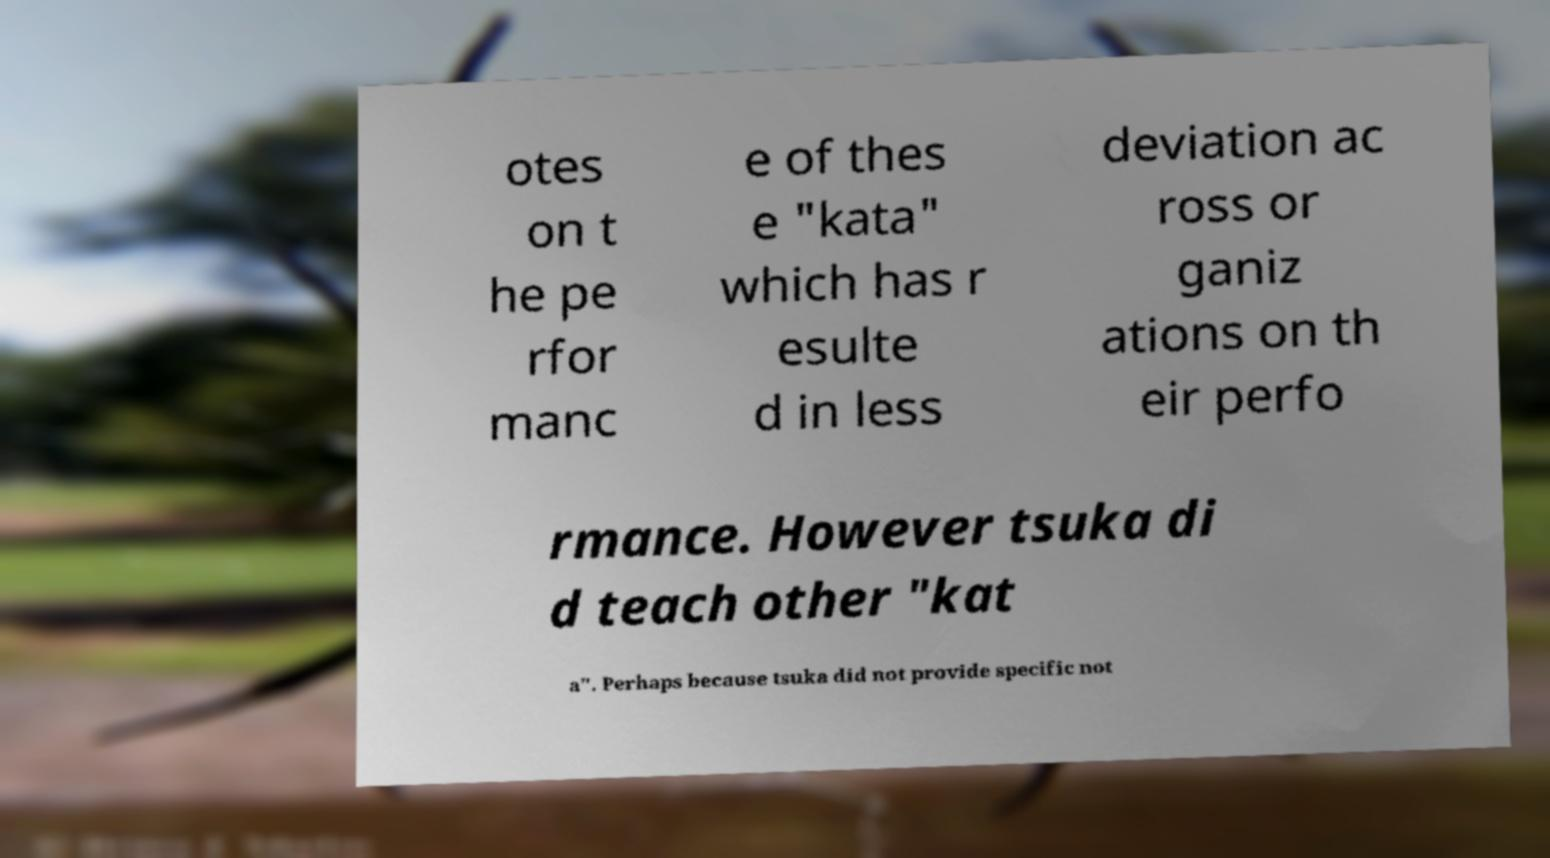Could you assist in decoding the text presented in this image and type it out clearly? otes on t he pe rfor manc e of thes e "kata" which has r esulte d in less deviation ac ross or ganiz ations on th eir perfo rmance. However tsuka di d teach other "kat a". Perhaps because tsuka did not provide specific not 